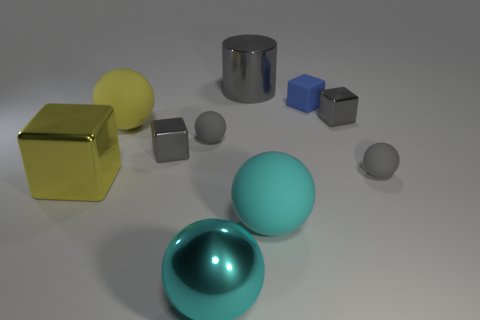What colors are predominantly present in this image, and do they create a specific atmosphere or visual effect? The predominant colors in the image are shades of gray, blue, and yellow. These colors, along with the lighting, create a calm and modern atmosphere. The simplicity and contrast between the objects and the background enhance the minimalist aesthetic of the scene. 